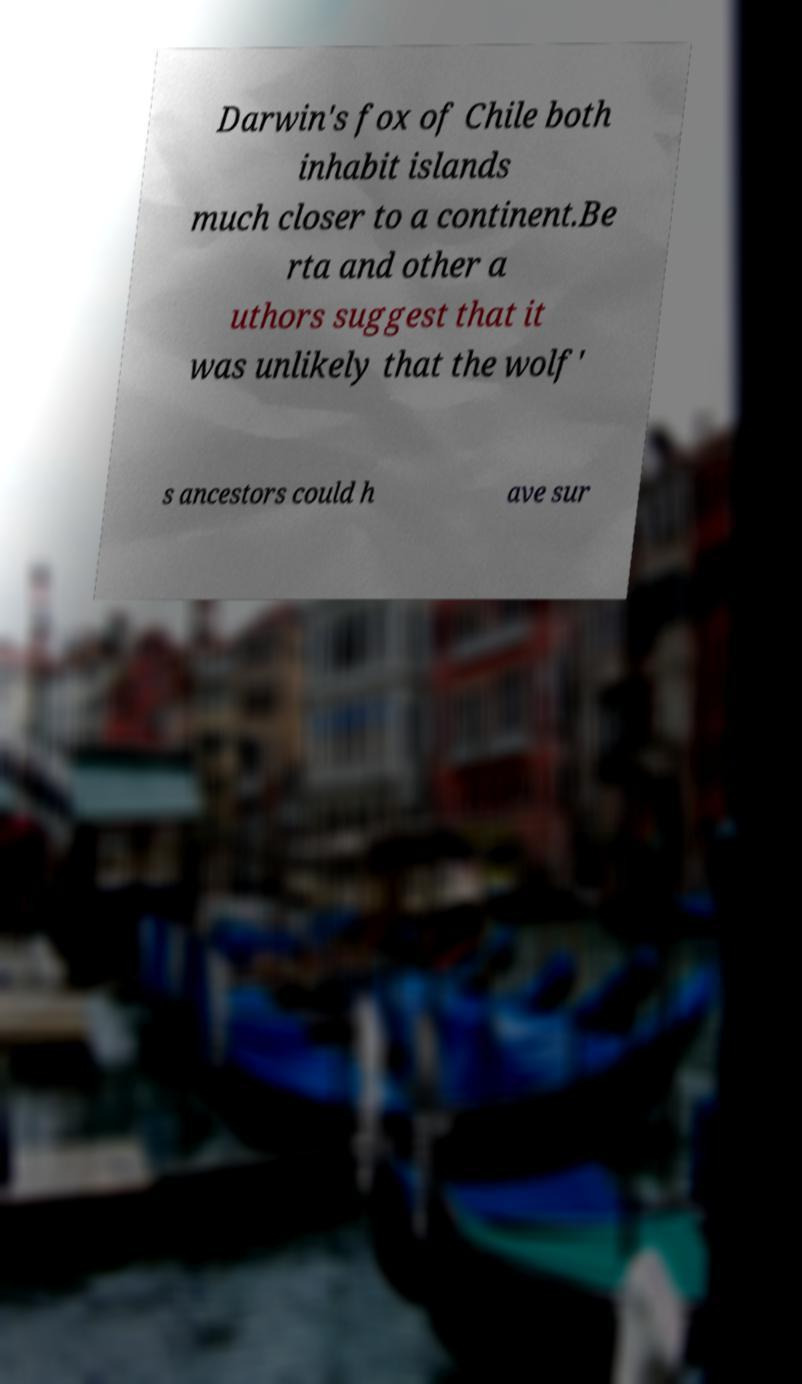Could you extract and type out the text from this image? Darwin's fox of Chile both inhabit islands much closer to a continent.Be rta and other a uthors suggest that it was unlikely that the wolf' s ancestors could h ave sur 